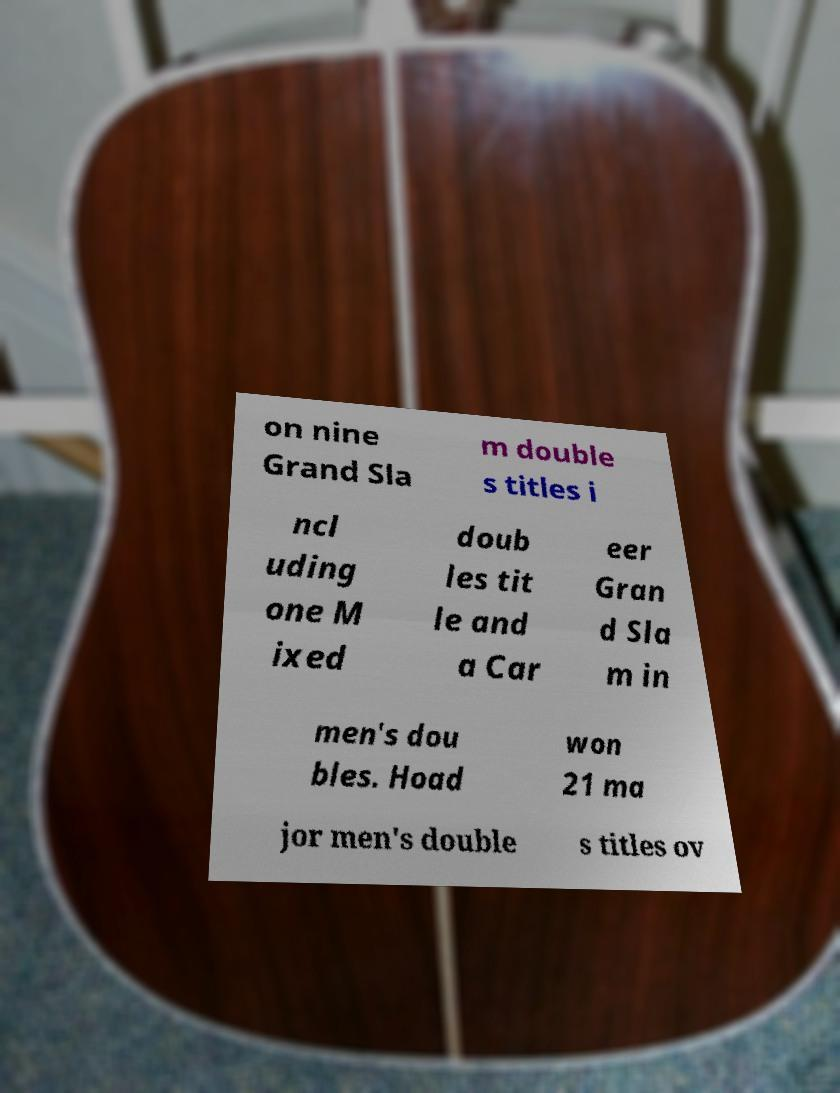There's text embedded in this image that I need extracted. Can you transcribe it verbatim? on nine Grand Sla m double s titles i ncl uding one M ixed doub les tit le and a Car eer Gran d Sla m in men's dou bles. Hoad won 21 ma jor men's double s titles ov 